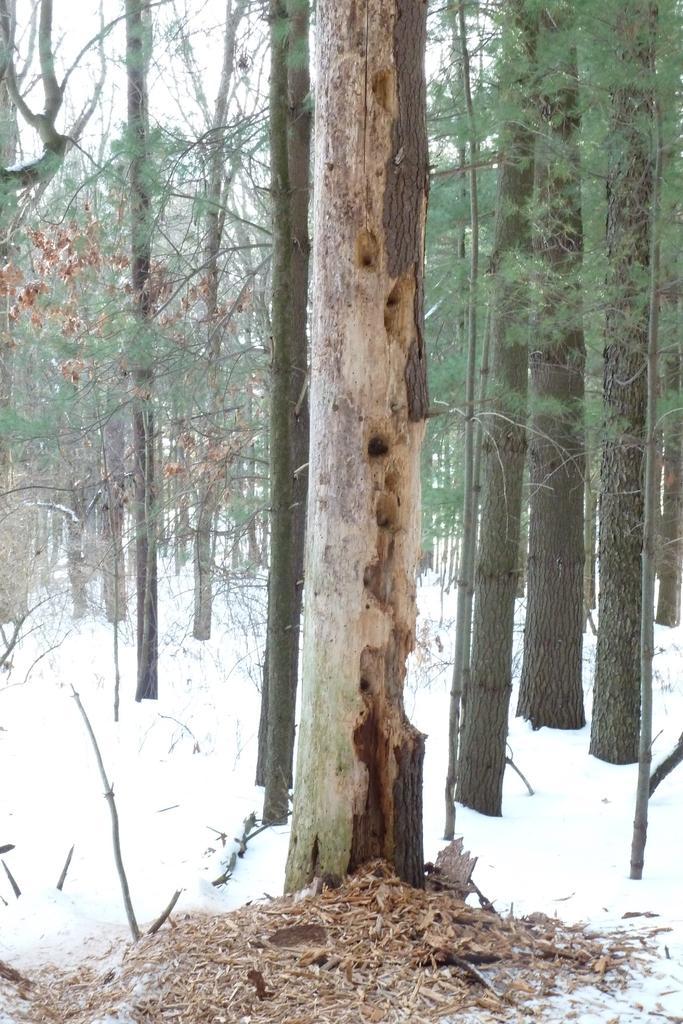How would you summarize this image in a sentence or two? In this picture i can see many trees. On the left i can see the snow. At the top there is a sky. 